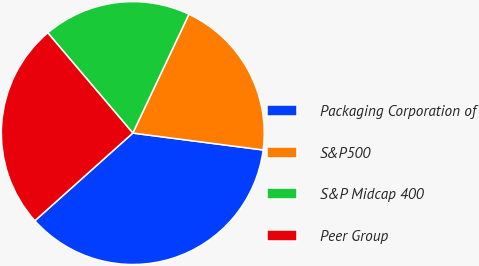<chart> <loc_0><loc_0><loc_500><loc_500><pie_chart><fcel>Packaging Corporation of<fcel>S&P500<fcel>S&P Midcap 400<fcel>Peer Group<nl><fcel>36.32%<fcel>20.03%<fcel>18.22%<fcel>25.42%<nl></chart> 